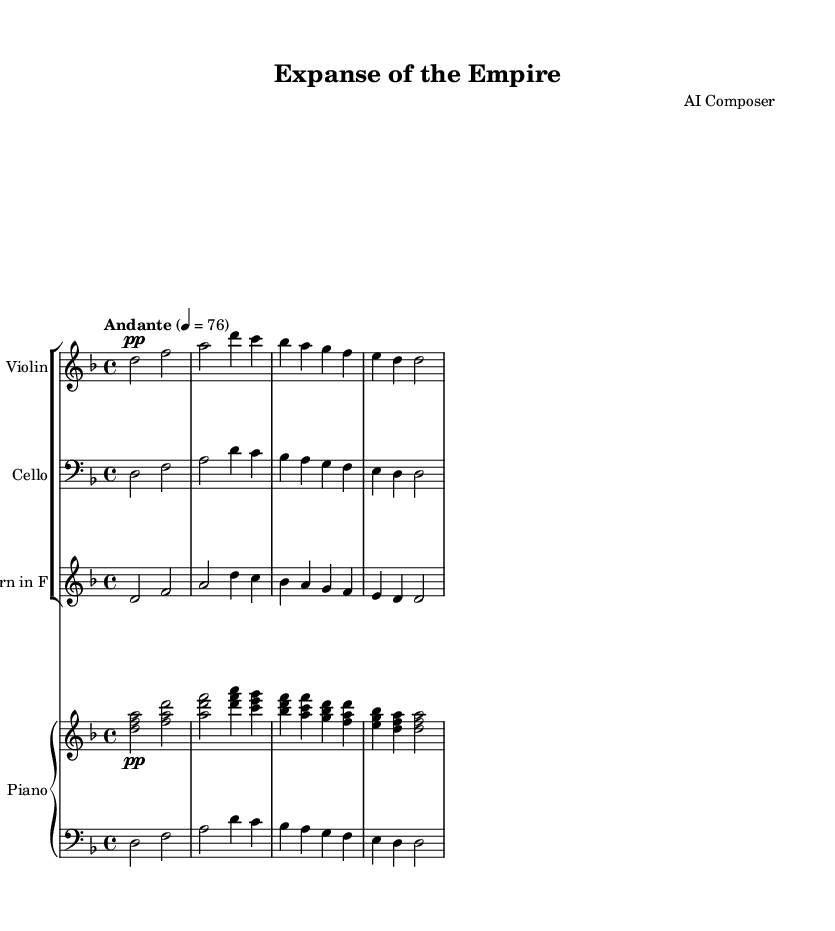What is the key signature of this music? The key signature is indicated by the number of sharps or flats at the beginning of the staff. In this case, the presence of one flat (B♭) indicates that the key is D minor.
Answer: D minor What is the time signature of this piece? The time signature is shown at the beginning of the music as two numbers stacked vertically. The presence of a 4 above a 4 indicates a common time signature of four beats per measure, also known as 4/4 time.
Answer: 4/4 What is the tempo marking of this composition? The tempo is indicated at the top of the music with the word "Andante" and a metronome marking of 76 beats per minute, which suggests a moderate walking pace.
Answer: Andante, 76 How many staves are present in the score? The score contains a total of four staves: one for the violin, one for the cello, one for the horn, and a piano staff which includes a right hand and a left hand part.
Answer: Four staves Which instrument has the clef denoted by the symbol that resembles a stylized G? The instrument with the G clef, often referred to as the treble clef, is typically associated with higher-pitched instruments. In this case, it is used for the violin and the right hand of the piano.
Answer: Violin and Piano (right hand) What is the dynamic marking for the first section of the music? The dynamic marking at the beginning of the violin part indicates the volume level, with "pp" specifying that it should be played very softly. This is located next to the first note at the beginning of the violin part.
Answer: pp What thematic element does the title "Expanse of the Empire" suggest regarding the composition? The title evokes imagery of the vast and diverse landscapes of Imperial Russia, hinting that the music may be inspired by the expansive territories and cultural richness of the empire. This thematic element can be inferred rather than explicitly stated within the sheet music itself.
Answer: Vastness of Imperial Russia 